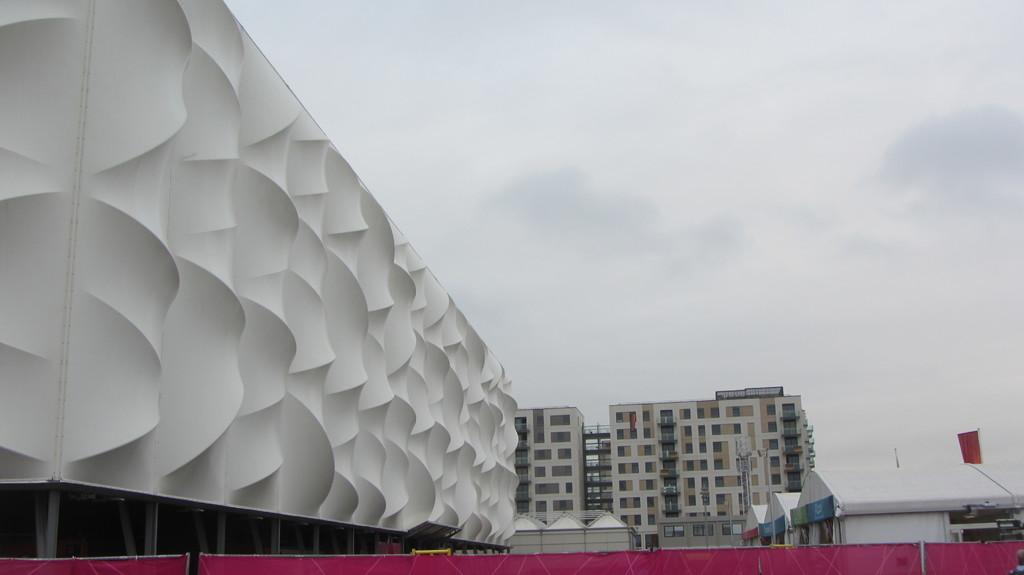What type of structures are present in the image? There is a group of buildings in the image. What additional element can be seen in the image? There is a flag in the image. What is visible in the background of the image? The sky is visible in the background of the image. How would you describe the weather based on the appearance of the sky? The sky appears to be cloudy in the image. What type of belief is represented by the tomatoes in the image? There are no tomatoes present in the image, so it is not possible to determine any beliefs represented by them. 